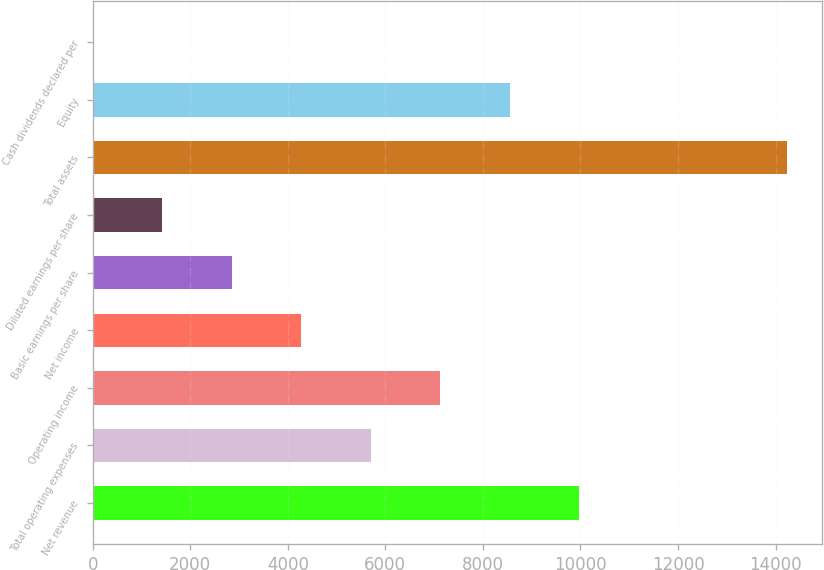<chart> <loc_0><loc_0><loc_500><loc_500><bar_chart><fcel>Net revenue<fcel>Total operating expenses<fcel>Operating income<fcel>Net income<fcel>Basic earnings per share<fcel>Diluted earnings per share<fcel>Total assets<fcel>Equity<fcel>Cash dividends declared per<nl><fcel>9969.48<fcel>5696.97<fcel>7121.14<fcel>4272.8<fcel>2848.63<fcel>1424.46<fcel>14242<fcel>8545.31<fcel>0.29<nl></chart> 